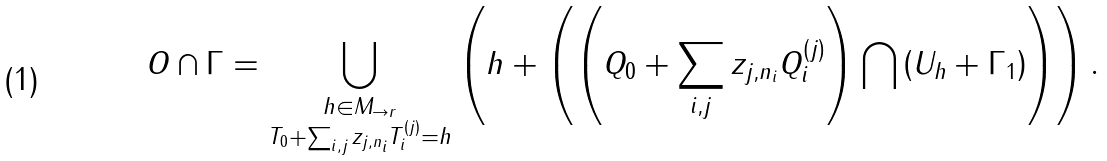Convert formula to latex. <formula><loc_0><loc_0><loc_500><loc_500>O \cap \Gamma = \bigcup _ { \substack { h \in M _ { \to r } \\ T _ { 0 } + \sum _ { i , j } z _ { j , n _ { i } } T ^ { ( j ) } _ { i } = h } } \left ( h + \left ( \left ( Q _ { 0 } + \sum _ { i , j } z _ { j , n _ { i } } Q ^ { ( j ) } _ { i } \right ) \bigcap \left ( U _ { h } + \Gamma _ { 1 } \right ) \right ) \right ) .</formula> 